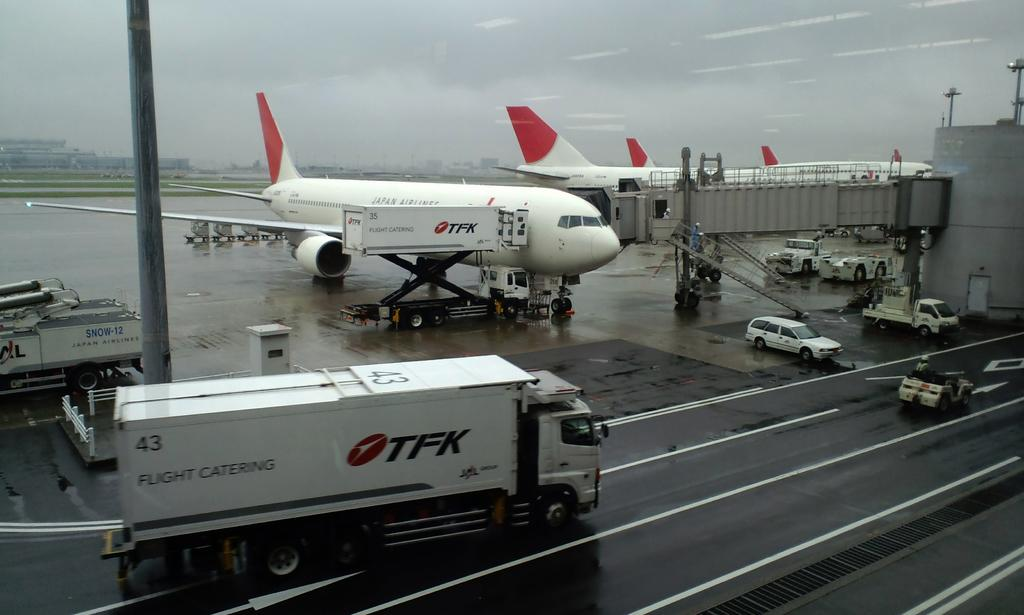<image>
Share a concise interpretation of the image provided. An airport landing with five planes from the airline TFK. 